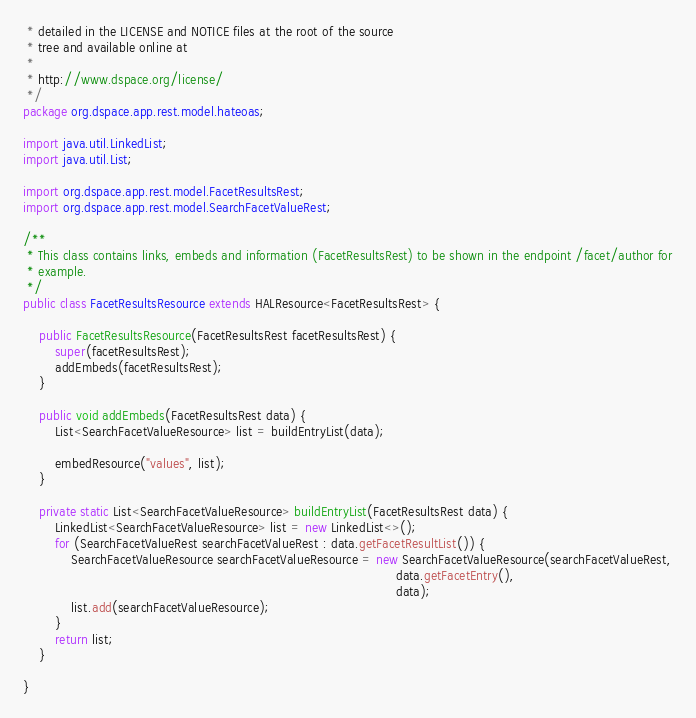Convert code to text. <code><loc_0><loc_0><loc_500><loc_500><_Java_> * detailed in the LICENSE and NOTICE files at the root of the source
 * tree and available online at
 *
 * http://www.dspace.org/license/
 */
package org.dspace.app.rest.model.hateoas;

import java.util.LinkedList;
import java.util.List;

import org.dspace.app.rest.model.FacetResultsRest;
import org.dspace.app.rest.model.SearchFacetValueRest;

/**
 * This class contains links, embeds and information (FacetResultsRest) to be shown in the endpoint /facet/author for
 * example.
 */
public class FacetResultsResource extends HALResource<FacetResultsRest> {

    public FacetResultsResource(FacetResultsRest facetResultsRest) {
        super(facetResultsRest);
        addEmbeds(facetResultsRest);
    }

    public void addEmbeds(FacetResultsRest data) {
        List<SearchFacetValueResource> list = buildEntryList(data);

        embedResource("values", list);
    }

    private static List<SearchFacetValueResource> buildEntryList(FacetResultsRest data) {
        LinkedList<SearchFacetValueResource> list = new LinkedList<>();
        for (SearchFacetValueRest searchFacetValueRest : data.getFacetResultList()) {
            SearchFacetValueResource searchFacetValueResource = new SearchFacetValueResource(searchFacetValueRest,
                                                                                             data.getFacetEntry(),
                                                                                             data);
            list.add(searchFacetValueResource);
        }
        return list;
    }

}
</code> 